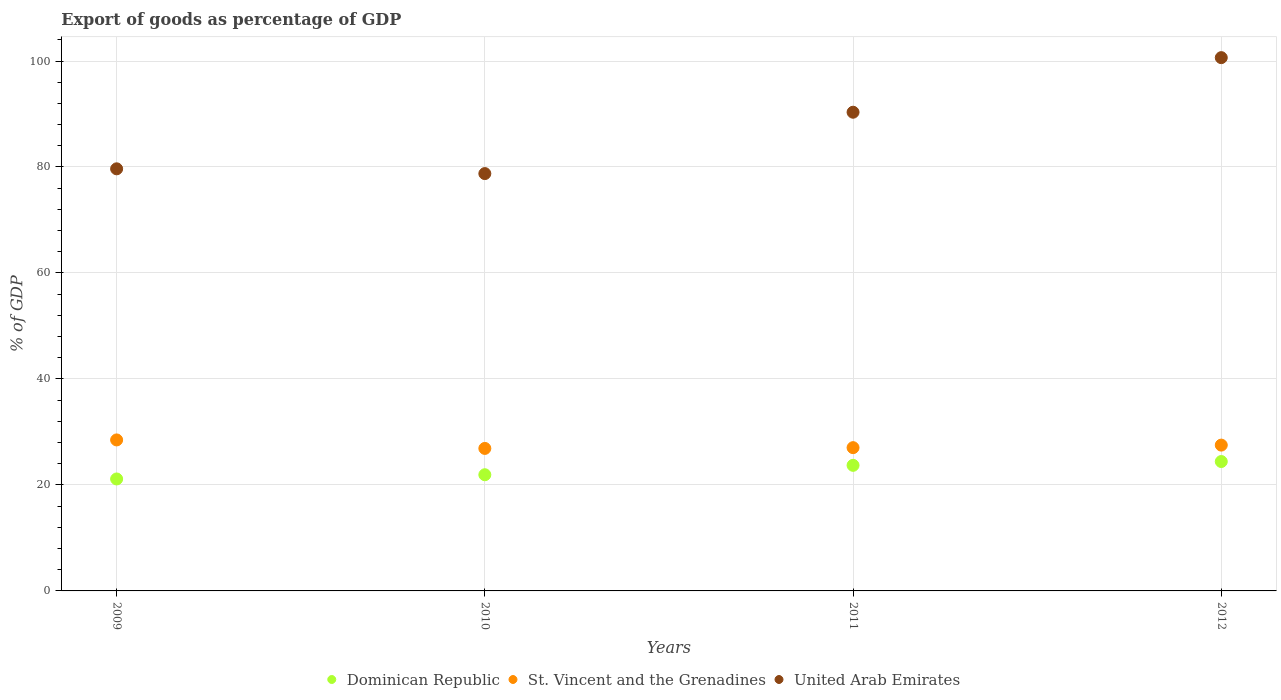How many different coloured dotlines are there?
Give a very brief answer. 3. What is the export of goods as percentage of GDP in St. Vincent and the Grenadines in 2012?
Provide a succinct answer. 27.52. Across all years, what is the maximum export of goods as percentage of GDP in Dominican Republic?
Your response must be concise. 24.42. Across all years, what is the minimum export of goods as percentage of GDP in United Arab Emirates?
Provide a short and direct response. 78.75. What is the total export of goods as percentage of GDP in St. Vincent and the Grenadines in the graph?
Offer a terse response. 109.94. What is the difference between the export of goods as percentage of GDP in United Arab Emirates in 2011 and that in 2012?
Provide a succinct answer. -10.3. What is the difference between the export of goods as percentage of GDP in United Arab Emirates in 2012 and the export of goods as percentage of GDP in St. Vincent and the Grenadines in 2010?
Your response must be concise. 73.74. What is the average export of goods as percentage of GDP in Dominican Republic per year?
Ensure brevity in your answer.  22.79. In the year 2011, what is the difference between the export of goods as percentage of GDP in Dominican Republic and export of goods as percentage of GDP in United Arab Emirates?
Keep it short and to the point. -66.63. What is the ratio of the export of goods as percentage of GDP in Dominican Republic in 2010 to that in 2012?
Offer a very short reply. 0.9. Is the export of goods as percentage of GDP in St. Vincent and the Grenadines in 2011 less than that in 2012?
Offer a very short reply. Yes. Is the difference between the export of goods as percentage of GDP in Dominican Republic in 2009 and 2012 greater than the difference between the export of goods as percentage of GDP in United Arab Emirates in 2009 and 2012?
Your response must be concise. Yes. What is the difference between the highest and the second highest export of goods as percentage of GDP in Dominican Republic?
Keep it short and to the point. 0.72. What is the difference between the highest and the lowest export of goods as percentage of GDP in Dominican Republic?
Keep it short and to the point. 3.29. In how many years, is the export of goods as percentage of GDP in St. Vincent and the Grenadines greater than the average export of goods as percentage of GDP in St. Vincent and the Grenadines taken over all years?
Make the answer very short. 2. Is the sum of the export of goods as percentage of GDP in Dominican Republic in 2010 and 2011 greater than the maximum export of goods as percentage of GDP in United Arab Emirates across all years?
Give a very brief answer. No. Is the export of goods as percentage of GDP in United Arab Emirates strictly less than the export of goods as percentage of GDP in St. Vincent and the Grenadines over the years?
Offer a very short reply. No. How many years are there in the graph?
Keep it short and to the point. 4. Are the values on the major ticks of Y-axis written in scientific E-notation?
Give a very brief answer. No. Does the graph contain any zero values?
Give a very brief answer. No. Does the graph contain grids?
Keep it short and to the point. Yes. Where does the legend appear in the graph?
Provide a short and direct response. Bottom center. How are the legend labels stacked?
Provide a short and direct response. Horizontal. What is the title of the graph?
Keep it short and to the point. Export of goods as percentage of GDP. Does "Curacao" appear as one of the legend labels in the graph?
Make the answer very short. No. What is the label or title of the X-axis?
Provide a succinct answer. Years. What is the label or title of the Y-axis?
Your response must be concise. % of GDP. What is the % of GDP of Dominican Republic in 2009?
Make the answer very short. 21.13. What is the % of GDP in St. Vincent and the Grenadines in 2009?
Keep it short and to the point. 28.49. What is the % of GDP of United Arab Emirates in 2009?
Your response must be concise. 79.65. What is the % of GDP of Dominican Republic in 2010?
Provide a short and direct response. 21.93. What is the % of GDP in St. Vincent and the Grenadines in 2010?
Your response must be concise. 26.89. What is the % of GDP of United Arab Emirates in 2010?
Provide a succinct answer. 78.75. What is the % of GDP in Dominican Republic in 2011?
Offer a very short reply. 23.7. What is the % of GDP in St. Vincent and the Grenadines in 2011?
Your answer should be very brief. 27.04. What is the % of GDP in United Arab Emirates in 2011?
Your response must be concise. 90.33. What is the % of GDP in Dominican Republic in 2012?
Offer a very short reply. 24.42. What is the % of GDP in St. Vincent and the Grenadines in 2012?
Provide a succinct answer. 27.52. What is the % of GDP of United Arab Emirates in 2012?
Your answer should be compact. 100.63. Across all years, what is the maximum % of GDP of Dominican Republic?
Your answer should be compact. 24.42. Across all years, what is the maximum % of GDP of St. Vincent and the Grenadines?
Keep it short and to the point. 28.49. Across all years, what is the maximum % of GDP in United Arab Emirates?
Keep it short and to the point. 100.63. Across all years, what is the minimum % of GDP in Dominican Republic?
Give a very brief answer. 21.13. Across all years, what is the minimum % of GDP in St. Vincent and the Grenadines?
Provide a short and direct response. 26.89. Across all years, what is the minimum % of GDP of United Arab Emirates?
Make the answer very short. 78.75. What is the total % of GDP in Dominican Republic in the graph?
Make the answer very short. 91.17. What is the total % of GDP of St. Vincent and the Grenadines in the graph?
Make the answer very short. 109.94. What is the total % of GDP of United Arab Emirates in the graph?
Provide a succinct answer. 349.37. What is the difference between the % of GDP in Dominican Republic in 2009 and that in 2010?
Ensure brevity in your answer.  -0.8. What is the difference between the % of GDP of St. Vincent and the Grenadines in 2009 and that in 2010?
Give a very brief answer. 1.6. What is the difference between the % of GDP in United Arab Emirates in 2009 and that in 2010?
Offer a terse response. 0.9. What is the difference between the % of GDP in Dominican Republic in 2009 and that in 2011?
Keep it short and to the point. -2.57. What is the difference between the % of GDP in St. Vincent and the Grenadines in 2009 and that in 2011?
Give a very brief answer. 1.46. What is the difference between the % of GDP of United Arab Emirates in 2009 and that in 2011?
Give a very brief answer. -10.68. What is the difference between the % of GDP of Dominican Republic in 2009 and that in 2012?
Your answer should be compact. -3.29. What is the difference between the % of GDP of St. Vincent and the Grenadines in 2009 and that in 2012?
Provide a short and direct response. 0.98. What is the difference between the % of GDP in United Arab Emirates in 2009 and that in 2012?
Your response must be concise. -20.98. What is the difference between the % of GDP of Dominican Republic in 2010 and that in 2011?
Provide a short and direct response. -1.77. What is the difference between the % of GDP of St. Vincent and the Grenadines in 2010 and that in 2011?
Give a very brief answer. -0.14. What is the difference between the % of GDP of United Arab Emirates in 2010 and that in 2011?
Keep it short and to the point. -11.58. What is the difference between the % of GDP of Dominican Republic in 2010 and that in 2012?
Your answer should be compact. -2.49. What is the difference between the % of GDP in St. Vincent and the Grenadines in 2010 and that in 2012?
Keep it short and to the point. -0.63. What is the difference between the % of GDP in United Arab Emirates in 2010 and that in 2012?
Ensure brevity in your answer.  -21.88. What is the difference between the % of GDP in Dominican Republic in 2011 and that in 2012?
Your answer should be very brief. -0.72. What is the difference between the % of GDP in St. Vincent and the Grenadines in 2011 and that in 2012?
Offer a terse response. -0.48. What is the difference between the % of GDP in United Arab Emirates in 2011 and that in 2012?
Keep it short and to the point. -10.3. What is the difference between the % of GDP of Dominican Republic in 2009 and the % of GDP of St. Vincent and the Grenadines in 2010?
Ensure brevity in your answer.  -5.76. What is the difference between the % of GDP in Dominican Republic in 2009 and the % of GDP in United Arab Emirates in 2010?
Offer a terse response. -57.63. What is the difference between the % of GDP of St. Vincent and the Grenadines in 2009 and the % of GDP of United Arab Emirates in 2010?
Provide a succinct answer. -50.26. What is the difference between the % of GDP in Dominican Republic in 2009 and the % of GDP in St. Vincent and the Grenadines in 2011?
Make the answer very short. -5.91. What is the difference between the % of GDP in Dominican Republic in 2009 and the % of GDP in United Arab Emirates in 2011?
Your answer should be compact. -69.21. What is the difference between the % of GDP of St. Vincent and the Grenadines in 2009 and the % of GDP of United Arab Emirates in 2011?
Offer a terse response. -61.84. What is the difference between the % of GDP in Dominican Republic in 2009 and the % of GDP in St. Vincent and the Grenadines in 2012?
Provide a short and direct response. -6.39. What is the difference between the % of GDP in Dominican Republic in 2009 and the % of GDP in United Arab Emirates in 2012?
Provide a short and direct response. -79.51. What is the difference between the % of GDP in St. Vincent and the Grenadines in 2009 and the % of GDP in United Arab Emirates in 2012?
Make the answer very short. -72.14. What is the difference between the % of GDP of Dominican Republic in 2010 and the % of GDP of St. Vincent and the Grenadines in 2011?
Make the answer very short. -5.11. What is the difference between the % of GDP in Dominican Republic in 2010 and the % of GDP in United Arab Emirates in 2011?
Offer a very short reply. -68.41. What is the difference between the % of GDP of St. Vincent and the Grenadines in 2010 and the % of GDP of United Arab Emirates in 2011?
Your answer should be very brief. -63.44. What is the difference between the % of GDP of Dominican Republic in 2010 and the % of GDP of St. Vincent and the Grenadines in 2012?
Keep it short and to the point. -5.59. What is the difference between the % of GDP of Dominican Republic in 2010 and the % of GDP of United Arab Emirates in 2012?
Give a very brief answer. -78.71. What is the difference between the % of GDP of St. Vincent and the Grenadines in 2010 and the % of GDP of United Arab Emirates in 2012?
Give a very brief answer. -73.74. What is the difference between the % of GDP of Dominican Republic in 2011 and the % of GDP of St. Vincent and the Grenadines in 2012?
Ensure brevity in your answer.  -3.82. What is the difference between the % of GDP of Dominican Republic in 2011 and the % of GDP of United Arab Emirates in 2012?
Provide a short and direct response. -76.94. What is the difference between the % of GDP in St. Vincent and the Grenadines in 2011 and the % of GDP in United Arab Emirates in 2012?
Provide a short and direct response. -73.6. What is the average % of GDP in Dominican Republic per year?
Give a very brief answer. 22.79. What is the average % of GDP in St. Vincent and the Grenadines per year?
Provide a short and direct response. 27.48. What is the average % of GDP in United Arab Emirates per year?
Give a very brief answer. 87.34. In the year 2009, what is the difference between the % of GDP in Dominican Republic and % of GDP in St. Vincent and the Grenadines?
Ensure brevity in your answer.  -7.37. In the year 2009, what is the difference between the % of GDP in Dominican Republic and % of GDP in United Arab Emirates?
Provide a short and direct response. -58.53. In the year 2009, what is the difference between the % of GDP in St. Vincent and the Grenadines and % of GDP in United Arab Emirates?
Keep it short and to the point. -51.16. In the year 2010, what is the difference between the % of GDP of Dominican Republic and % of GDP of St. Vincent and the Grenadines?
Your answer should be very brief. -4.97. In the year 2010, what is the difference between the % of GDP in Dominican Republic and % of GDP in United Arab Emirates?
Your answer should be very brief. -56.83. In the year 2010, what is the difference between the % of GDP of St. Vincent and the Grenadines and % of GDP of United Arab Emirates?
Offer a terse response. -51.86. In the year 2011, what is the difference between the % of GDP in Dominican Republic and % of GDP in St. Vincent and the Grenadines?
Offer a terse response. -3.34. In the year 2011, what is the difference between the % of GDP of Dominican Republic and % of GDP of United Arab Emirates?
Offer a terse response. -66.63. In the year 2011, what is the difference between the % of GDP of St. Vincent and the Grenadines and % of GDP of United Arab Emirates?
Provide a succinct answer. -63.3. In the year 2012, what is the difference between the % of GDP of Dominican Republic and % of GDP of St. Vincent and the Grenadines?
Provide a succinct answer. -3.1. In the year 2012, what is the difference between the % of GDP of Dominican Republic and % of GDP of United Arab Emirates?
Ensure brevity in your answer.  -76.22. In the year 2012, what is the difference between the % of GDP in St. Vincent and the Grenadines and % of GDP in United Arab Emirates?
Provide a short and direct response. -73.12. What is the ratio of the % of GDP in Dominican Republic in 2009 to that in 2010?
Your answer should be compact. 0.96. What is the ratio of the % of GDP in St. Vincent and the Grenadines in 2009 to that in 2010?
Your response must be concise. 1.06. What is the ratio of the % of GDP of United Arab Emirates in 2009 to that in 2010?
Provide a succinct answer. 1.01. What is the ratio of the % of GDP in Dominican Republic in 2009 to that in 2011?
Offer a terse response. 0.89. What is the ratio of the % of GDP in St. Vincent and the Grenadines in 2009 to that in 2011?
Ensure brevity in your answer.  1.05. What is the ratio of the % of GDP in United Arab Emirates in 2009 to that in 2011?
Offer a terse response. 0.88. What is the ratio of the % of GDP of Dominican Republic in 2009 to that in 2012?
Give a very brief answer. 0.87. What is the ratio of the % of GDP in St. Vincent and the Grenadines in 2009 to that in 2012?
Provide a succinct answer. 1.04. What is the ratio of the % of GDP in United Arab Emirates in 2009 to that in 2012?
Provide a short and direct response. 0.79. What is the ratio of the % of GDP in Dominican Republic in 2010 to that in 2011?
Keep it short and to the point. 0.93. What is the ratio of the % of GDP in United Arab Emirates in 2010 to that in 2011?
Offer a very short reply. 0.87. What is the ratio of the % of GDP in Dominican Republic in 2010 to that in 2012?
Your answer should be compact. 0.9. What is the ratio of the % of GDP of St. Vincent and the Grenadines in 2010 to that in 2012?
Offer a very short reply. 0.98. What is the ratio of the % of GDP of United Arab Emirates in 2010 to that in 2012?
Ensure brevity in your answer.  0.78. What is the ratio of the % of GDP of Dominican Republic in 2011 to that in 2012?
Give a very brief answer. 0.97. What is the ratio of the % of GDP in St. Vincent and the Grenadines in 2011 to that in 2012?
Provide a succinct answer. 0.98. What is the ratio of the % of GDP of United Arab Emirates in 2011 to that in 2012?
Your answer should be compact. 0.9. What is the difference between the highest and the second highest % of GDP of Dominican Republic?
Your response must be concise. 0.72. What is the difference between the highest and the second highest % of GDP in St. Vincent and the Grenadines?
Keep it short and to the point. 0.98. What is the difference between the highest and the second highest % of GDP in United Arab Emirates?
Offer a very short reply. 10.3. What is the difference between the highest and the lowest % of GDP of Dominican Republic?
Provide a succinct answer. 3.29. What is the difference between the highest and the lowest % of GDP in St. Vincent and the Grenadines?
Ensure brevity in your answer.  1.6. What is the difference between the highest and the lowest % of GDP of United Arab Emirates?
Your answer should be very brief. 21.88. 